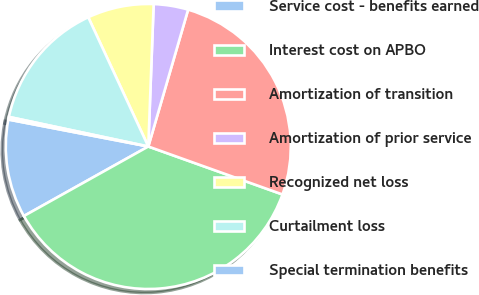Convert chart to OTSL. <chart><loc_0><loc_0><loc_500><loc_500><pie_chart><fcel>Service cost - benefits earned<fcel>Interest cost on APBO<fcel>Amortization of transition<fcel>Amortization of prior service<fcel>Recognized net loss<fcel>Curtailment loss<fcel>Special termination benefits<nl><fcel>11.14%<fcel>36.43%<fcel>25.96%<fcel>3.91%<fcel>7.52%<fcel>14.75%<fcel>0.3%<nl></chart> 